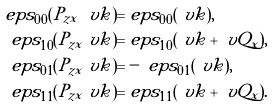Convert formula to latex. <formula><loc_0><loc_0><loc_500><loc_500>\ e p s _ { 0 0 } ( P _ { z x } \ v k ) = & \ e p s _ { 0 0 } ( \ v k ) , \\ \ e p s _ { 1 0 } ( P _ { z x } \ v k ) = & \ e p s _ { 1 0 } ( \ v k + \ v Q _ { x } ) , \\ \ e p s _ { 0 1 } ( P _ { z x } \ v k ) = & - \ e p s _ { 0 1 } ( \ v k ) , \\ \ e p s _ { 1 1 } ( P _ { z x } \ v k ) = & \ e p s _ { 1 1 } ( \ v k + \ v Q _ { x } ) .</formula> 